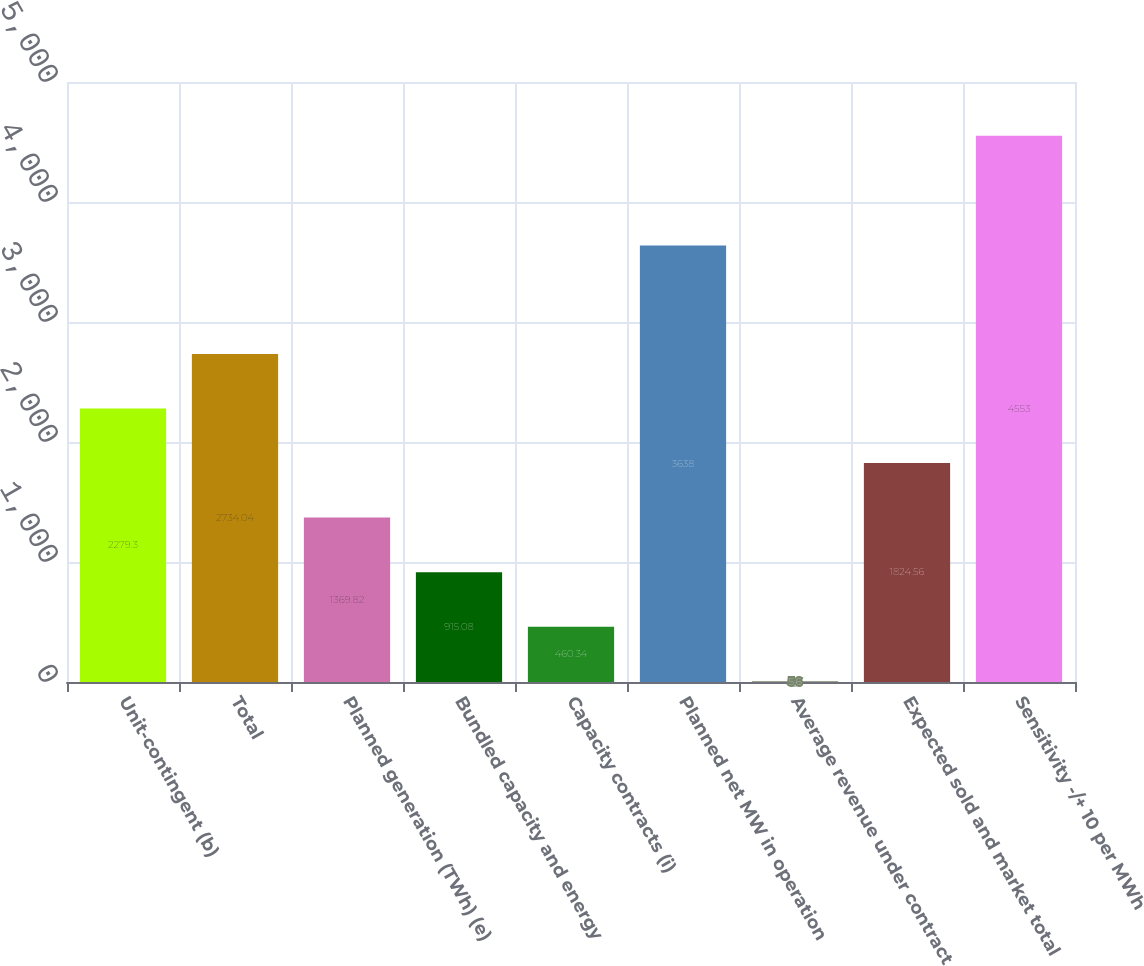<chart> <loc_0><loc_0><loc_500><loc_500><bar_chart><fcel>Unit-contingent (b)<fcel>Total<fcel>Planned generation (TWh) (e)<fcel>Bundled capacity and energy<fcel>Capacity contracts (i)<fcel>Planned net MW in operation<fcel>Average revenue under contract<fcel>Expected sold and market total<fcel>Sensitivity -/+ 10 per MWh<nl><fcel>2279.3<fcel>2734.04<fcel>1369.82<fcel>915.08<fcel>460.34<fcel>3638<fcel>5.6<fcel>1824.56<fcel>4553<nl></chart> 